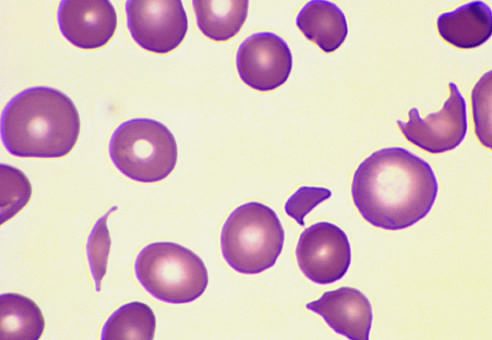what contains several fragmented red cells?
Answer the question using a single word or phrase. This specimen from patient with hemolytic uremic syndrome 